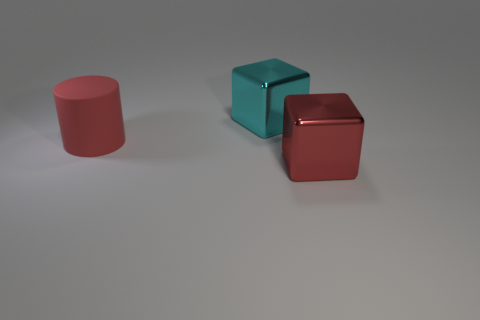Do the red metal object and the object behind the large matte cylinder have the same shape?
Offer a terse response. Yes. How many things are to the left of the large red metallic block and right of the big red cylinder?
Keep it short and to the point. 1. What material is the other thing that is the same shape as the large cyan metallic thing?
Offer a very short reply. Metal. There is a metallic thing left of the big metallic object that is in front of the large red cylinder; what is its size?
Your response must be concise. Large. Are there any red cylinders?
Offer a very short reply. Yes. What is the material of the object that is both behind the large red metal cube and on the right side of the big cylinder?
Keep it short and to the point. Metal. Are there more red things right of the big cylinder than big red things that are behind the large red metal object?
Offer a terse response. No. Are there any blue shiny balls of the same size as the cyan block?
Keep it short and to the point. No. There is a red thing that is right of the block to the left of the shiny object to the right of the cyan cube; how big is it?
Ensure brevity in your answer.  Large. What color is the big rubber cylinder?
Offer a terse response. Red. 